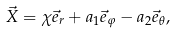<formula> <loc_0><loc_0><loc_500><loc_500>\vec { X } = \chi \vec { e } _ { r } + a _ { 1 } \vec { e } _ { \varphi } - a _ { 2 } \vec { e } _ { \theta } ,</formula> 